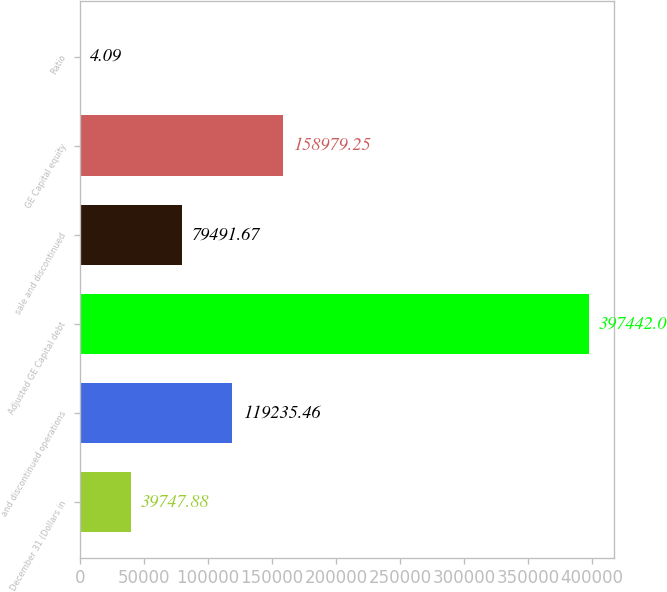<chart> <loc_0><loc_0><loc_500><loc_500><bar_chart><fcel>December 31 (Dollars in<fcel>and discontinued operations<fcel>Adjusted GE Capital debt<fcel>sale and discontinued<fcel>GE Capital equity<fcel>Ratio<nl><fcel>39747.9<fcel>119235<fcel>397442<fcel>79491.7<fcel>158979<fcel>4.09<nl></chart> 